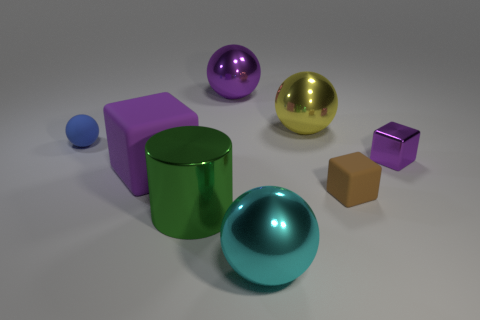Is the number of small purple blocks less than the number of large matte cylinders?
Ensure brevity in your answer.  No. The shiny thing that is both in front of the tiny blue matte sphere and behind the cylinder is what color?
Provide a short and direct response. Purple. There is a small blue thing that is the same shape as the cyan metallic object; what is its material?
Provide a short and direct response. Rubber. Are there any other things that are the same size as the brown rubber thing?
Keep it short and to the point. Yes. Is the number of matte cubes greater than the number of brown matte blocks?
Provide a succinct answer. Yes. There is a shiny thing that is left of the large cyan metallic sphere and behind the small sphere; how big is it?
Provide a short and direct response. Large. There is a big yellow object; what shape is it?
Give a very brief answer. Sphere. What number of red metallic objects are the same shape as the yellow shiny thing?
Your response must be concise. 0. Is the number of tiny purple blocks that are behind the big yellow object less than the number of purple cubes that are on the right side of the purple metal sphere?
Offer a terse response. Yes. There is a small matte object in front of the small purple metallic cube; what number of yellow balls are to the right of it?
Keep it short and to the point. 0. 